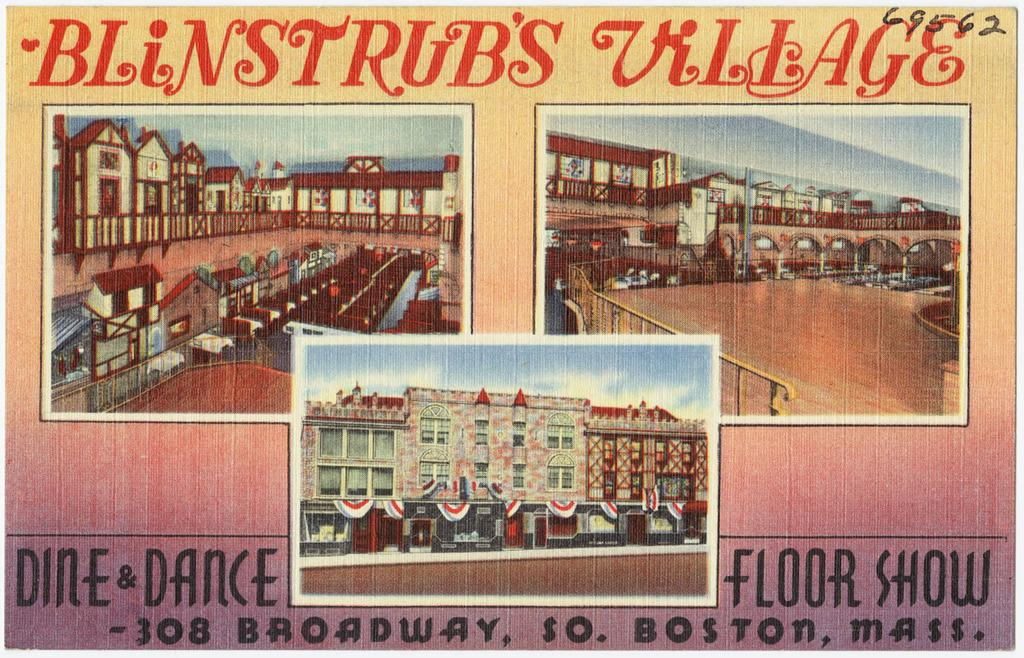<image>
Create a compact narrative representing the image presented. An advertisement poster for Blinstrub's Village in Boston, Massachusetts. 